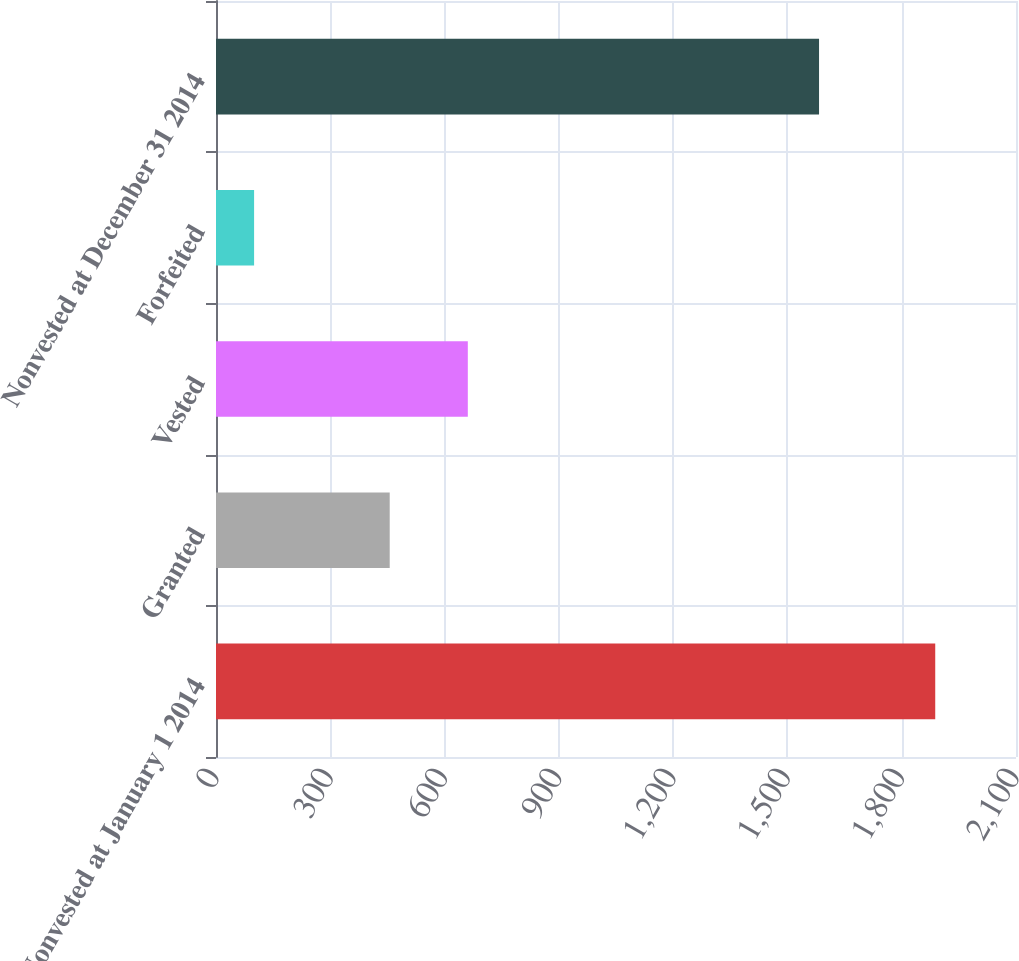Convert chart to OTSL. <chart><loc_0><loc_0><loc_500><loc_500><bar_chart><fcel>Nonvested at January 1 2014<fcel>Granted<fcel>Vested<fcel>Forfeited<fcel>Nonvested at December 31 2014<nl><fcel>1888<fcel>456<fcel>661<fcel>100<fcel>1583<nl></chart> 